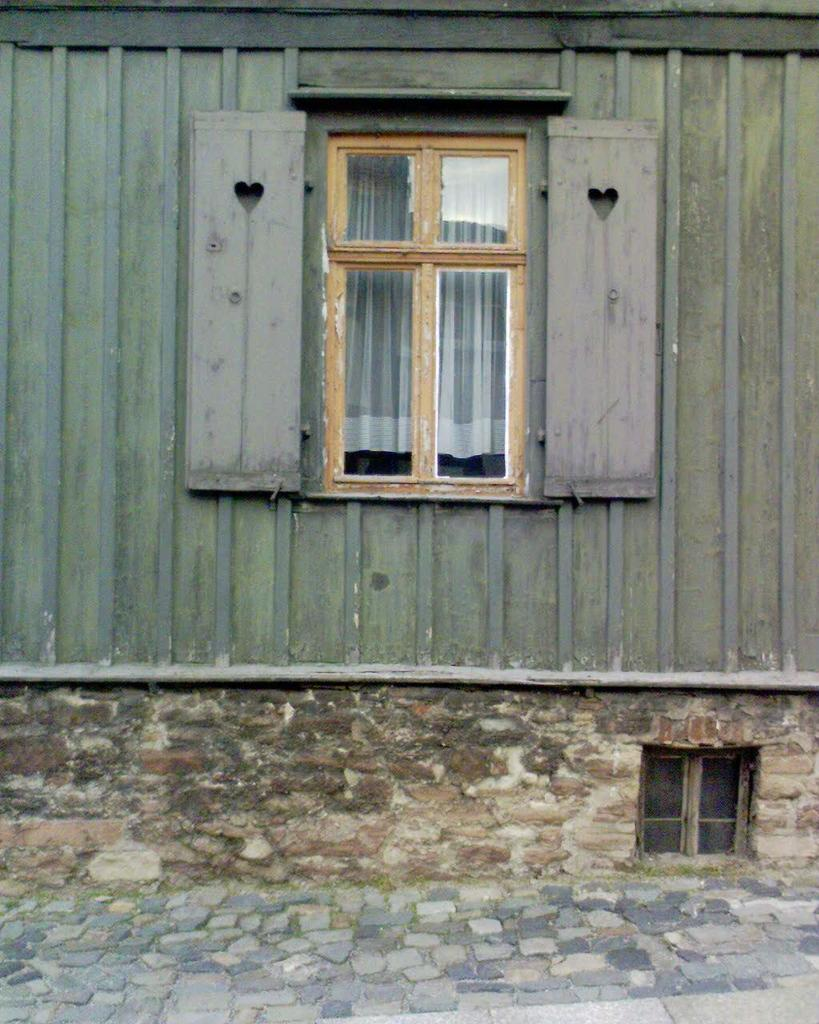What is present on the wall in the image? There is a tin on top of the wall in the image. What other architectural feature can be seen in the image? There is a window in the image. What type of fruit is hanging from the window in the image? There is no fruit hanging from the window in the image. What kind of brass decoration can be seen on the wall in the image? There is no brass decoration present in the image. 